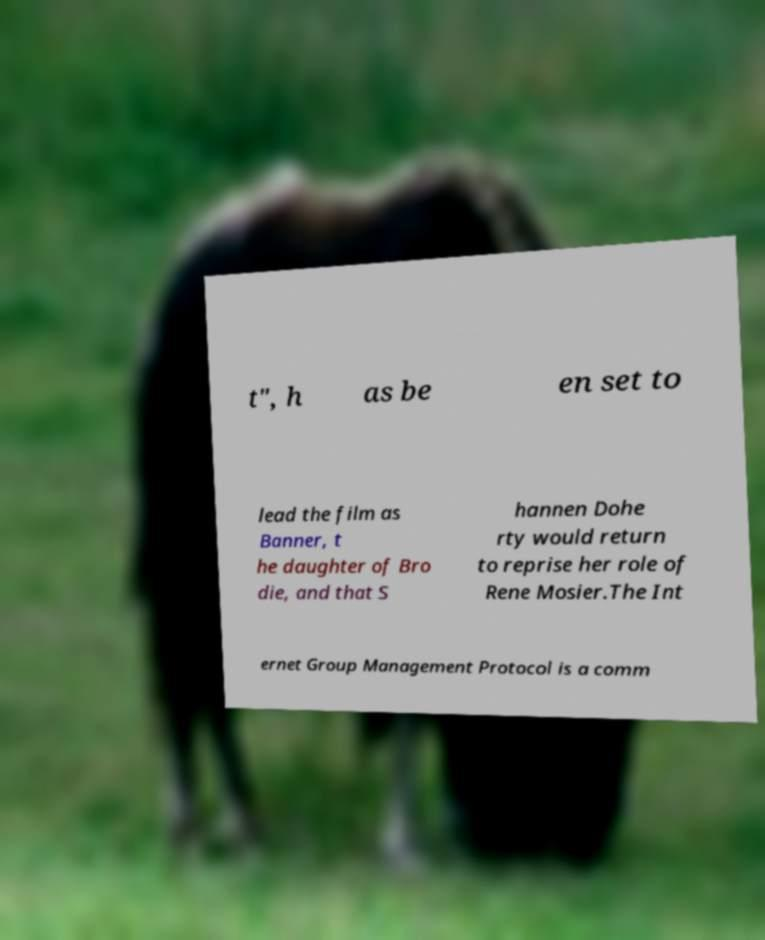I need the written content from this picture converted into text. Can you do that? t", h as be en set to lead the film as Banner, t he daughter of Bro die, and that S hannen Dohe rty would return to reprise her role of Rene Mosier.The Int ernet Group Management Protocol is a comm 